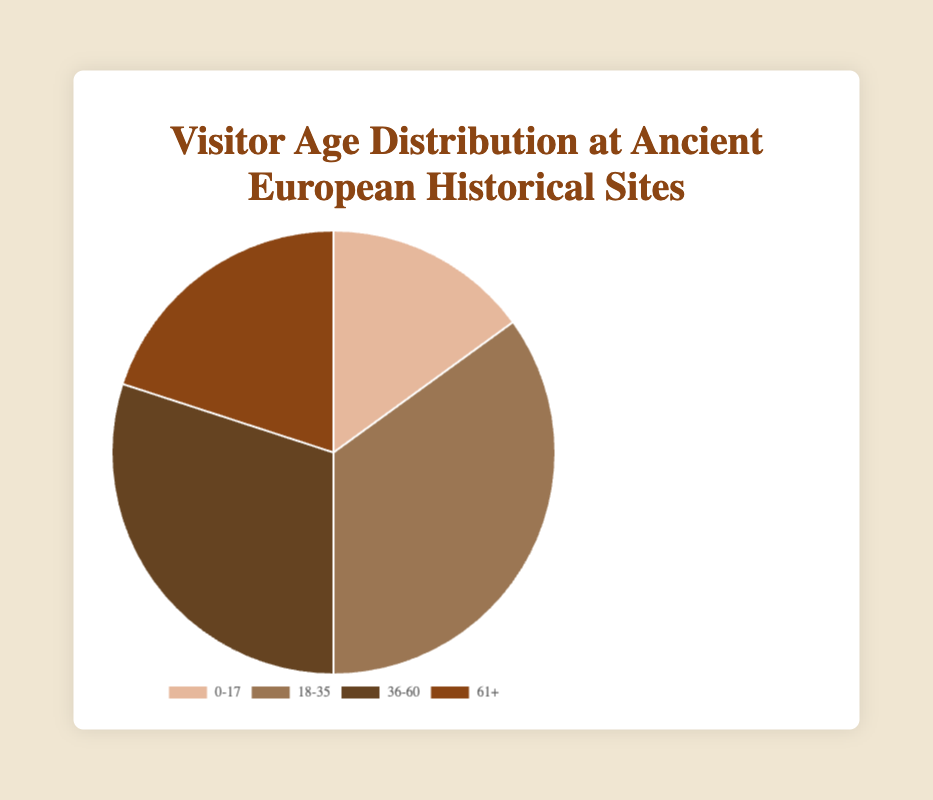What's the most visited age group at ancient European historical sites? The age group with the highest percentage in the pie chart is the most visited. The 18-35 age group has the highest percentage at 35%.
Answer: 18-35 age group Which two age groups have an equal or higher percentage of visitors than the age group 36-60? The 36-60 age group has 30% visitors. The age groups with a higher or equal percentage are 18-35 (35%) and 36-60 itself (30%).
Answer: 18-35 and 36-60 age groups Which age group has the smallest representation? Identify the age group with the smallest percentage by looking at the pie chart. The 0-17 age group has the smallest representation at 15%.
Answer: 0-17 age group What percentage of visitors are aged 35 or younger? Sum the percentages of the 0-17 and 18-35 age groups. 15% (0-17) + 35% (18-35) = 50%.
Answer: 50% How much greater is the percentage of young adults (18-35) compared to children (0-17)? Subtract the percentage of children (0-17) from young adults (18-35). 35% - 15% = 20%.
Answer: 20% greater What is the combined percentage of visitors aged 36 or older? Sum the percentages of the 36-60 and 61+ age groups. 30% (36-60) + 20% (61+) = 50%.
Answer: 50% Which age group is represented by the darkest color in the pie chart? The pie chart's colors range from lighter to darker shades. The 61+ age group is represented by the darkest color.
Answer: 61+ age group Are there more visitors in the 0-17 age group than in the 61+ age group? Compare the percentages of the 0-17 and 61+ age groups. 0-17 has 15% visitors, while 61+ has 20% visitors.
Answer: No Which two age groups together make up exactly half of the total visitors? Sum the percentages of different combinations until a total of 50% is found. Combining 0-17 (15%) and 36-60 (30%) results in 45%, which is too low. Combining 0-17 (15%) and 61+ (20%) results in 35%, also too low. Combining 36-60 (30%) and 61+ (20%) results in 50%, which is correct.
Answer: 36-60 and 61+ What fraction of visitors are seniors (61+)? The fraction is simply given by the percentage converted into a fraction. 20% of 100% is 20/100, which simplifies to 1/5.
Answer: 1/5 